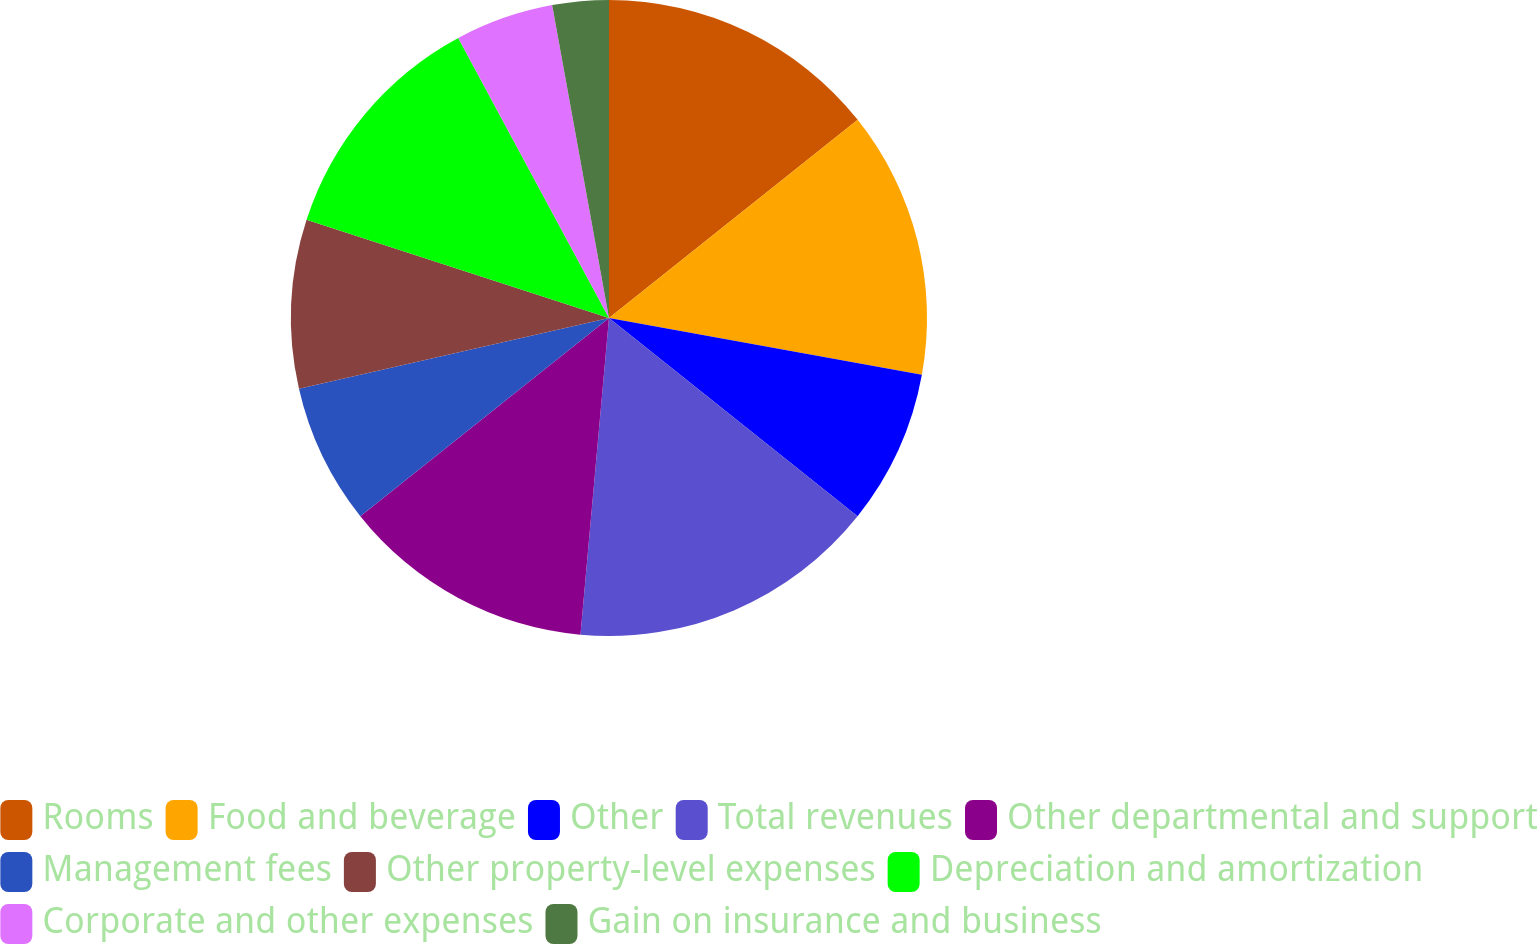Convert chart. <chart><loc_0><loc_0><loc_500><loc_500><pie_chart><fcel>Rooms<fcel>Food and beverage<fcel>Other<fcel>Total revenues<fcel>Other departmental and support<fcel>Management fees<fcel>Other property-level expenses<fcel>Depreciation and amortization<fcel>Corporate and other expenses<fcel>Gain on insurance and business<nl><fcel>14.29%<fcel>13.57%<fcel>7.86%<fcel>15.71%<fcel>12.86%<fcel>7.14%<fcel>8.57%<fcel>12.14%<fcel>5.0%<fcel>2.86%<nl></chart> 